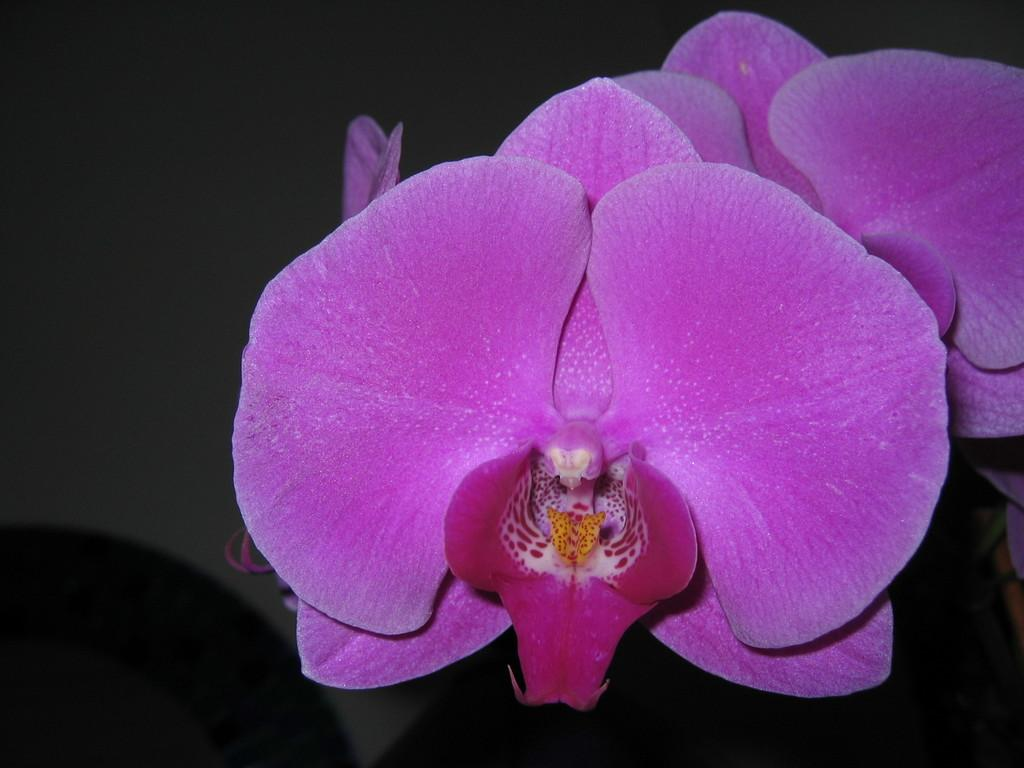What type of flowers can be seen in the image? There are pink color flowers in the image. How many roads can be seen in the image? There are no roads present in the image; it only features pink color flowers. What type of burn can be observed on the flowers in the image? There is no burn present on the flowers in the image; they appear to be healthy and undamaged. 